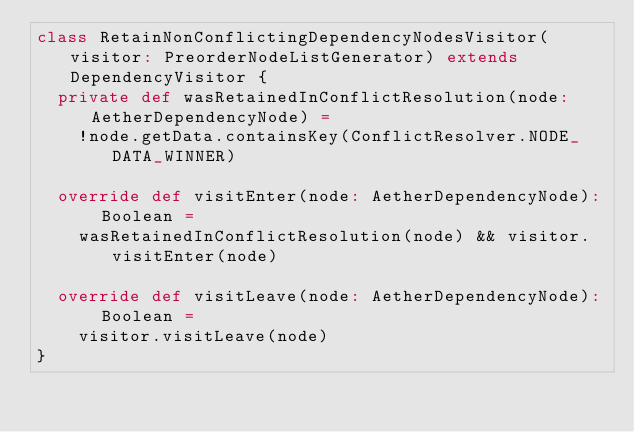<code> <loc_0><loc_0><loc_500><loc_500><_Scala_>class RetainNonConflictingDependencyNodesVisitor(visitor: PreorderNodeListGenerator) extends DependencyVisitor {
  private def wasRetainedInConflictResolution(node: AetherDependencyNode) =
    !node.getData.containsKey(ConflictResolver.NODE_DATA_WINNER)

  override def visitEnter(node: AetherDependencyNode): Boolean =
    wasRetainedInConflictResolution(node) && visitor.visitEnter(node)

  override def visitLeave(node: AetherDependencyNode): Boolean =
    visitor.visitLeave(node)
}</code> 